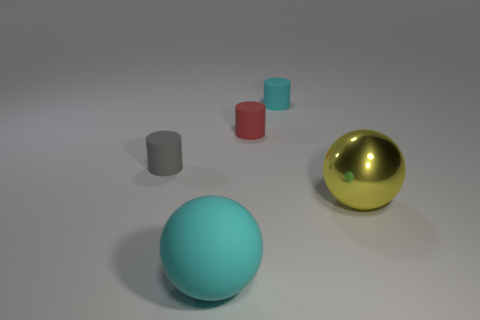Add 1 small brown shiny blocks. How many objects exist? 6 Subtract all spheres. How many objects are left? 3 Subtract 0 yellow blocks. How many objects are left? 5 Subtract all gray cylinders. Subtract all gray matte objects. How many objects are left? 3 Add 3 rubber things. How many rubber things are left? 7 Add 1 large red balls. How many large red balls exist? 1 